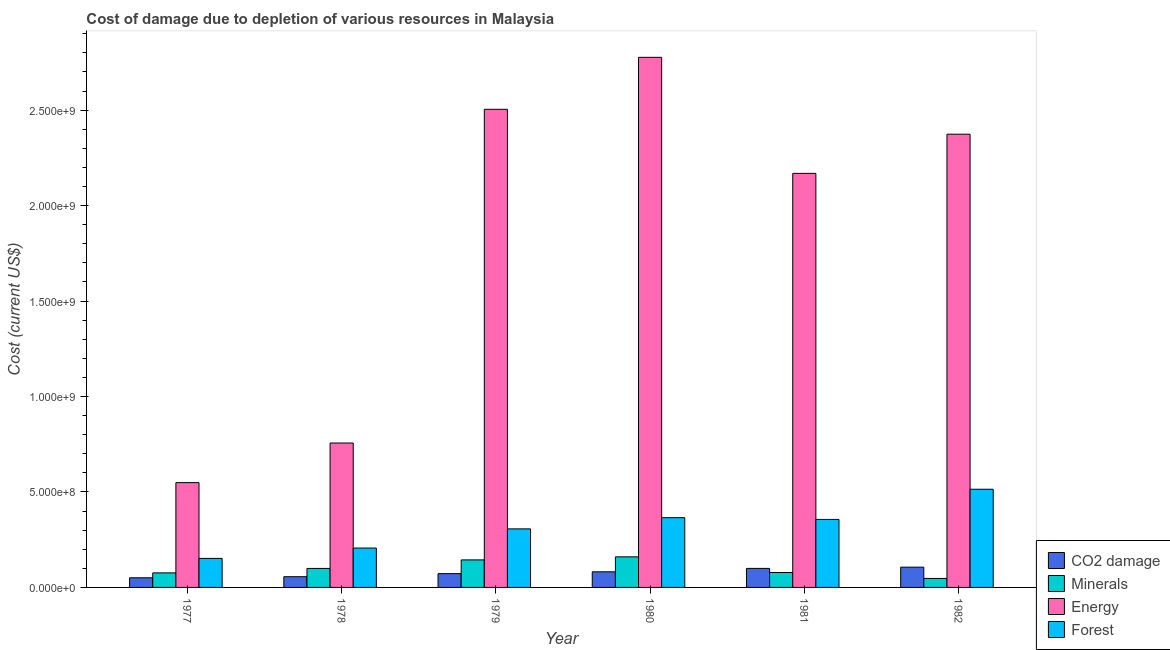How many different coloured bars are there?
Your answer should be compact. 4. How many groups of bars are there?
Your response must be concise. 6. Are the number of bars on each tick of the X-axis equal?
Your answer should be compact. Yes. What is the label of the 2nd group of bars from the left?
Offer a very short reply. 1978. What is the cost of damage due to depletion of forests in 1979?
Your answer should be very brief. 3.07e+08. Across all years, what is the maximum cost of damage due to depletion of energy?
Provide a succinct answer. 2.78e+09. Across all years, what is the minimum cost of damage due to depletion of forests?
Offer a terse response. 1.52e+08. In which year was the cost of damage due to depletion of minerals maximum?
Your response must be concise. 1980. What is the total cost of damage due to depletion of forests in the graph?
Keep it short and to the point. 1.90e+09. What is the difference between the cost of damage due to depletion of energy in 1978 and that in 1979?
Provide a succinct answer. -1.75e+09. What is the difference between the cost of damage due to depletion of forests in 1979 and the cost of damage due to depletion of minerals in 1982?
Provide a short and direct response. -2.08e+08. What is the average cost of damage due to depletion of energy per year?
Your response must be concise. 1.85e+09. What is the ratio of the cost of damage due to depletion of energy in 1977 to that in 1979?
Ensure brevity in your answer.  0.22. What is the difference between the highest and the second highest cost of damage due to depletion of minerals?
Provide a succinct answer. 1.60e+07. What is the difference between the highest and the lowest cost of damage due to depletion of coal?
Provide a short and direct response. 5.57e+07. Is it the case that in every year, the sum of the cost of damage due to depletion of coal and cost of damage due to depletion of minerals is greater than the sum of cost of damage due to depletion of energy and cost of damage due to depletion of forests?
Offer a very short reply. No. What does the 4th bar from the left in 1982 represents?
Your response must be concise. Forest. What does the 1st bar from the right in 1977 represents?
Your answer should be compact. Forest. What is the difference between two consecutive major ticks on the Y-axis?
Offer a terse response. 5.00e+08. Are the values on the major ticks of Y-axis written in scientific E-notation?
Ensure brevity in your answer.  Yes. Does the graph contain grids?
Keep it short and to the point. No. How many legend labels are there?
Give a very brief answer. 4. What is the title of the graph?
Your response must be concise. Cost of damage due to depletion of various resources in Malaysia . What is the label or title of the Y-axis?
Ensure brevity in your answer.  Cost (current US$). What is the Cost (current US$) of CO2 damage in 1977?
Your answer should be very brief. 5.05e+07. What is the Cost (current US$) in Minerals in 1977?
Your answer should be very brief. 7.62e+07. What is the Cost (current US$) of Energy in 1977?
Give a very brief answer. 5.49e+08. What is the Cost (current US$) of Forest in 1977?
Your response must be concise. 1.52e+08. What is the Cost (current US$) in CO2 damage in 1978?
Your answer should be very brief. 5.62e+07. What is the Cost (current US$) in Minerals in 1978?
Your answer should be compact. 9.95e+07. What is the Cost (current US$) of Energy in 1978?
Ensure brevity in your answer.  7.56e+08. What is the Cost (current US$) in Forest in 1978?
Your response must be concise. 2.06e+08. What is the Cost (current US$) in CO2 damage in 1979?
Offer a very short reply. 7.23e+07. What is the Cost (current US$) of Minerals in 1979?
Ensure brevity in your answer.  1.44e+08. What is the Cost (current US$) of Energy in 1979?
Ensure brevity in your answer.  2.50e+09. What is the Cost (current US$) in Forest in 1979?
Make the answer very short. 3.07e+08. What is the Cost (current US$) of CO2 damage in 1980?
Your answer should be very brief. 8.18e+07. What is the Cost (current US$) in Minerals in 1980?
Ensure brevity in your answer.  1.60e+08. What is the Cost (current US$) in Energy in 1980?
Provide a succinct answer. 2.78e+09. What is the Cost (current US$) of Forest in 1980?
Provide a short and direct response. 3.65e+08. What is the Cost (current US$) in CO2 damage in 1981?
Keep it short and to the point. 9.96e+07. What is the Cost (current US$) in Minerals in 1981?
Your answer should be compact. 7.82e+07. What is the Cost (current US$) of Energy in 1981?
Give a very brief answer. 2.17e+09. What is the Cost (current US$) in Forest in 1981?
Make the answer very short. 3.56e+08. What is the Cost (current US$) of CO2 damage in 1982?
Provide a short and direct response. 1.06e+08. What is the Cost (current US$) in Minerals in 1982?
Provide a short and direct response. 4.71e+07. What is the Cost (current US$) of Energy in 1982?
Your response must be concise. 2.37e+09. What is the Cost (current US$) of Forest in 1982?
Offer a terse response. 5.14e+08. Across all years, what is the maximum Cost (current US$) of CO2 damage?
Your answer should be very brief. 1.06e+08. Across all years, what is the maximum Cost (current US$) of Minerals?
Your response must be concise. 1.60e+08. Across all years, what is the maximum Cost (current US$) of Energy?
Make the answer very short. 2.78e+09. Across all years, what is the maximum Cost (current US$) in Forest?
Your answer should be compact. 5.14e+08. Across all years, what is the minimum Cost (current US$) in CO2 damage?
Your answer should be very brief. 5.05e+07. Across all years, what is the minimum Cost (current US$) in Minerals?
Provide a succinct answer. 4.71e+07. Across all years, what is the minimum Cost (current US$) of Energy?
Provide a short and direct response. 5.49e+08. Across all years, what is the minimum Cost (current US$) of Forest?
Ensure brevity in your answer.  1.52e+08. What is the total Cost (current US$) of CO2 damage in the graph?
Keep it short and to the point. 4.67e+08. What is the total Cost (current US$) of Minerals in the graph?
Keep it short and to the point. 6.05e+08. What is the total Cost (current US$) in Energy in the graph?
Ensure brevity in your answer.  1.11e+1. What is the total Cost (current US$) in Forest in the graph?
Provide a short and direct response. 1.90e+09. What is the difference between the Cost (current US$) of CO2 damage in 1977 and that in 1978?
Ensure brevity in your answer.  -5.70e+06. What is the difference between the Cost (current US$) in Minerals in 1977 and that in 1978?
Make the answer very short. -2.33e+07. What is the difference between the Cost (current US$) of Energy in 1977 and that in 1978?
Keep it short and to the point. -2.07e+08. What is the difference between the Cost (current US$) in Forest in 1977 and that in 1978?
Make the answer very short. -5.43e+07. What is the difference between the Cost (current US$) in CO2 damage in 1977 and that in 1979?
Your response must be concise. -2.18e+07. What is the difference between the Cost (current US$) in Minerals in 1977 and that in 1979?
Provide a short and direct response. -6.80e+07. What is the difference between the Cost (current US$) of Energy in 1977 and that in 1979?
Ensure brevity in your answer.  -1.96e+09. What is the difference between the Cost (current US$) in Forest in 1977 and that in 1979?
Make the answer very short. -1.55e+08. What is the difference between the Cost (current US$) of CO2 damage in 1977 and that in 1980?
Your answer should be compact. -3.13e+07. What is the difference between the Cost (current US$) in Minerals in 1977 and that in 1980?
Give a very brief answer. -8.40e+07. What is the difference between the Cost (current US$) in Energy in 1977 and that in 1980?
Your response must be concise. -2.23e+09. What is the difference between the Cost (current US$) of Forest in 1977 and that in 1980?
Give a very brief answer. -2.13e+08. What is the difference between the Cost (current US$) in CO2 damage in 1977 and that in 1981?
Keep it short and to the point. -4.91e+07. What is the difference between the Cost (current US$) in Minerals in 1977 and that in 1981?
Offer a terse response. -1.99e+06. What is the difference between the Cost (current US$) of Energy in 1977 and that in 1981?
Ensure brevity in your answer.  -1.62e+09. What is the difference between the Cost (current US$) in Forest in 1977 and that in 1981?
Your answer should be compact. -2.04e+08. What is the difference between the Cost (current US$) in CO2 damage in 1977 and that in 1982?
Provide a succinct answer. -5.57e+07. What is the difference between the Cost (current US$) in Minerals in 1977 and that in 1982?
Offer a terse response. 2.91e+07. What is the difference between the Cost (current US$) in Energy in 1977 and that in 1982?
Offer a terse response. -1.82e+09. What is the difference between the Cost (current US$) of Forest in 1977 and that in 1982?
Make the answer very short. -3.62e+08. What is the difference between the Cost (current US$) of CO2 damage in 1978 and that in 1979?
Give a very brief answer. -1.61e+07. What is the difference between the Cost (current US$) of Minerals in 1978 and that in 1979?
Your response must be concise. -4.46e+07. What is the difference between the Cost (current US$) of Energy in 1978 and that in 1979?
Your answer should be very brief. -1.75e+09. What is the difference between the Cost (current US$) of Forest in 1978 and that in 1979?
Offer a terse response. -1.00e+08. What is the difference between the Cost (current US$) in CO2 damage in 1978 and that in 1980?
Provide a short and direct response. -2.56e+07. What is the difference between the Cost (current US$) of Minerals in 1978 and that in 1980?
Your answer should be compact. -6.06e+07. What is the difference between the Cost (current US$) of Energy in 1978 and that in 1980?
Your response must be concise. -2.02e+09. What is the difference between the Cost (current US$) of Forest in 1978 and that in 1980?
Provide a succinct answer. -1.59e+08. What is the difference between the Cost (current US$) of CO2 damage in 1978 and that in 1981?
Ensure brevity in your answer.  -4.34e+07. What is the difference between the Cost (current US$) in Minerals in 1978 and that in 1981?
Keep it short and to the point. 2.14e+07. What is the difference between the Cost (current US$) in Energy in 1978 and that in 1981?
Offer a terse response. -1.41e+09. What is the difference between the Cost (current US$) in Forest in 1978 and that in 1981?
Offer a terse response. -1.50e+08. What is the difference between the Cost (current US$) in CO2 damage in 1978 and that in 1982?
Your answer should be very brief. -5.00e+07. What is the difference between the Cost (current US$) of Minerals in 1978 and that in 1982?
Keep it short and to the point. 5.24e+07. What is the difference between the Cost (current US$) in Energy in 1978 and that in 1982?
Keep it short and to the point. -1.62e+09. What is the difference between the Cost (current US$) of Forest in 1978 and that in 1982?
Give a very brief answer. -3.08e+08. What is the difference between the Cost (current US$) of CO2 damage in 1979 and that in 1980?
Keep it short and to the point. -9.54e+06. What is the difference between the Cost (current US$) of Minerals in 1979 and that in 1980?
Offer a very short reply. -1.60e+07. What is the difference between the Cost (current US$) in Energy in 1979 and that in 1980?
Your answer should be very brief. -2.72e+08. What is the difference between the Cost (current US$) of Forest in 1979 and that in 1980?
Ensure brevity in your answer.  -5.87e+07. What is the difference between the Cost (current US$) of CO2 damage in 1979 and that in 1981?
Your answer should be compact. -2.74e+07. What is the difference between the Cost (current US$) in Minerals in 1979 and that in 1981?
Your answer should be compact. 6.60e+07. What is the difference between the Cost (current US$) in Energy in 1979 and that in 1981?
Make the answer very short. 3.36e+08. What is the difference between the Cost (current US$) in Forest in 1979 and that in 1981?
Ensure brevity in your answer.  -4.96e+07. What is the difference between the Cost (current US$) of CO2 damage in 1979 and that in 1982?
Your answer should be very brief. -3.39e+07. What is the difference between the Cost (current US$) of Minerals in 1979 and that in 1982?
Provide a short and direct response. 9.70e+07. What is the difference between the Cost (current US$) in Energy in 1979 and that in 1982?
Your answer should be very brief. 1.30e+08. What is the difference between the Cost (current US$) of Forest in 1979 and that in 1982?
Your answer should be compact. -2.08e+08. What is the difference between the Cost (current US$) of CO2 damage in 1980 and that in 1981?
Ensure brevity in your answer.  -1.78e+07. What is the difference between the Cost (current US$) of Minerals in 1980 and that in 1981?
Your answer should be very brief. 8.20e+07. What is the difference between the Cost (current US$) in Energy in 1980 and that in 1981?
Keep it short and to the point. 6.08e+08. What is the difference between the Cost (current US$) of Forest in 1980 and that in 1981?
Keep it short and to the point. 9.09e+06. What is the difference between the Cost (current US$) in CO2 damage in 1980 and that in 1982?
Your response must be concise. -2.44e+07. What is the difference between the Cost (current US$) of Minerals in 1980 and that in 1982?
Offer a terse response. 1.13e+08. What is the difference between the Cost (current US$) of Energy in 1980 and that in 1982?
Provide a short and direct response. 4.03e+08. What is the difference between the Cost (current US$) of Forest in 1980 and that in 1982?
Provide a short and direct response. -1.49e+08. What is the difference between the Cost (current US$) of CO2 damage in 1981 and that in 1982?
Your answer should be very brief. -6.55e+06. What is the difference between the Cost (current US$) of Minerals in 1981 and that in 1982?
Offer a very short reply. 3.10e+07. What is the difference between the Cost (current US$) of Energy in 1981 and that in 1982?
Your answer should be very brief. -2.05e+08. What is the difference between the Cost (current US$) of Forest in 1981 and that in 1982?
Ensure brevity in your answer.  -1.58e+08. What is the difference between the Cost (current US$) in CO2 damage in 1977 and the Cost (current US$) in Minerals in 1978?
Your response must be concise. -4.90e+07. What is the difference between the Cost (current US$) in CO2 damage in 1977 and the Cost (current US$) in Energy in 1978?
Your answer should be compact. -7.06e+08. What is the difference between the Cost (current US$) of CO2 damage in 1977 and the Cost (current US$) of Forest in 1978?
Offer a very short reply. -1.56e+08. What is the difference between the Cost (current US$) of Minerals in 1977 and the Cost (current US$) of Energy in 1978?
Provide a short and direct response. -6.80e+08. What is the difference between the Cost (current US$) in Minerals in 1977 and the Cost (current US$) in Forest in 1978?
Make the answer very short. -1.30e+08. What is the difference between the Cost (current US$) of Energy in 1977 and the Cost (current US$) of Forest in 1978?
Offer a terse response. 3.43e+08. What is the difference between the Cost (current US$) of CO2 damage in 1977 and the Cost (current US$) of Minerals in 1979?
Provide a short and direct response. -9.37e+07. What is the difference between the Cost (current US$) in CO2 damage in 1977 and the Cost (current US$) in Energy in 1979?
Give a very brief answer. -2.45e+09. What is the difference between the Cost (current US$) in CO2 damage in 1977 and the Cost (current US$) in Forest in 1979?
Offer a very short reply. -2.56e+08. What is the difference between the Cost (current US$) of Minerals in 1977 and the Cost (current US$) of Energy in 1979?
Ensure brevity in your answer.  -2.43e+09. What is the difference between the Cost (current US$) of Minerals in 1977 and the Cost (current US$) of Forest in 1979?
Provide a succinct answer. -2.30e+08. What is the difference between the Cost (current US$) of Energy in 1977 and the Cost (current US$) of Forest in 1979?
Offer a terse response. 2.42e+08. What is the difference between the Cost (current US$) of CO2 damage in 1977 and the Cost (current US$) of Minerals in 1980?
Ensure brevity in your answer.  -1.10e+08. What is the difference between the Cost (current US$) of CO2 damage in 1977 and the Cost (current US$) of Energy in 1980?
Make the answer very short. -2.73e+09. What is the difference between the Cost (current US$) in CO2 damage in 1977 and the Cost (current US$) in Forest in 1980?
Your answer should be very brief. -3.15e+08. What is the difference between the Cost (current US$) in Minerals in 1977 and the Cost (current US$) in Energy in 1980?
Your response must be concise. -2.70e+09. What is the difference between the Cost (current US$) of Minerals in 1977 and the Cost (current US$) of Forest in 1980?
Ensure brevity in your answer.  -2.89e+08. What is the difference between the Cost (current US$) in Energy in 1977 and the Cost (current US$) in Forest in 1980?
Offer a very short reply. 1.84e+08. What is the difference between the Cost (current US$) of CO2 damage in 1977 and the Cost (current US$) of Minerals in 1981?
Keep it short and to the point. -2.77e+07. What is the difference between the Cost (current US$) of CO2 damage in 1977 and the Cost (current US$) of Energy in 1981?
Provide a short and direct response. -2.12e+09. What is the difference between the Cost (current US$) of CO2 damage in 1977 and the Cost (current US$) of Forest in 1981?
Offer a terse response. -3.06e+08. What is the difference between the Cost (current US$) in Minerals in 1977 and the Cost (current US$) in Energy in 1981?
Provide a short and direct response. -2.09e+09. What is the difference between the Cost (current US$) of Minerals in 1977 and the Cost (current US$) of Forest in 1981?
Give a very brief answer. -2.80e+08. What is the difference between the Cost (current US$) in Energy in 1977 and the Cost (current US$) in Forest in 1981?
Your answer should be very brief. 1.93e+08. What is the difference between the Cost (current US$) in CO2 damage in 1977 and the Cost (current US$) in Minerals in 1982?
Your response must be concise. 3.37e+06. What is the difference between the Cost (current US$) of CO2 damage in 1977 and the Cost (current US$) of Energy in 1982?
Offer a very short reply. -2.32e+09. What is the difference between the Cost (current US$) of CO2 damage in 1977 and the Cost (current US$) of Forest in 1982?
Your answer should be very brief. -4.64e+08. What is the difference between the Cost (current US$) in Minerals in 1977 and the Cost (current US$) in Energy in 1982?
Keep it short and to the point. -2.30e+09. What is the difference between the Cost (current US$) in Minerals in 1977 and the Cost (current US$) in Forest in 1982?
Offer a terse response. -4.38e+08. What is the difference between the Cost (current US$) of Energy in 1977 and the Cost (current US$) of Forest in 1982?
Offer a very short reply. 3.47e+07. What is the difference between the Cost (current US$) of CO2 damage in 1978 and the Cost (current US$) of Minerals in 1979?
Give a very brief answer. -8.80e+07. What is the difference between the Cost (current US$) of CO2 damage in 1978 and the Cost (current US$) of Energy in 1979?
Your answer should be compact. -2.45e+09. What is the difference between the Cost (current US$) in CO2 damage in 1978 and the Cost (current US$) in Forest in 1979?
Offer a terse response. -2.50e+08. What is the difference between the Cost (current US$) in Minerals in 1978 and the Cost (current US$) in Energy in 1979?
Your response must be concise. -2.40e+09. What is the difference between the Cost (current US$) of Minerals in 1978 and the Cost (current US$) of Forest in 1979?
Provide a short and direct response. -2.07e+08. What is the difference between the Cost (current US$) of Energy in 1978 and the Cost (current US$) of Forest in 1979?
Provide a short and direct response. 4.50e+08. What is the difference between the Cost (current US$) of CO2 damage in 1978 and the Cost (current US$) of Minerals in 1980?
Your answer should be very brief. -1.04e+08. What is the difference between the Cost (current US$) of CO2 damage in 1978 and the Cost (current US$) of Energy in 1980?
Keep it short and to the point. -2.72e+09. What is the difference between the Cost (current US$) in CO2 damage in 1978 and the Cost (current US$) in Forest in 1980?
Your answer should be compact. -3.09e+08. What is the difference between the Cost (current US$) in Minerals in 1978 and the Cost (current US$) in Energy in 1980?
Provide a succinct answer. -2.68e+09. What is the difference between the Cost (current US$) in Minerals in 1978 and the Cost (current US$) in Forest in 1980?
Offer a very short reply. -2.66e+08. What is the difference between the Cost (current US$) of Energy in 1978 and the Cost (current US$) of Forest in 1980?
Offer a terse response. 3.91e+08. What is the difference between the Cost (current US$) of CO2 damage in 1978 and the Cost (current US$) of Minerals in 1981?
Provide a short and direct response. -2.20e+07. What is the difference between the Cost (current US$) of CO2 damage in 1978 and the Cost (current US$) of Energy in 1981?
Ensure brevity in your answer.  -2.11e+09. What is the difference between the Cost (current US$) of CO2 damage in 1978 and the Cost (current US$) of Forest in 1981?
Keep it short and to the point. -3.00e+08. What is the difference between the Cost (current US$) of Minerals in 1978 and the Cost (current US$) of Energy in 1981?
Offer a terse response. -2.07e+09. What is the difference between the Cost (current US$) of Minerals in 1978 and the Cost (current US$) of Forest in 1981?
Provide a short and direct response. -2.57e+08. What is the difference between the Cost (current US$) of Energy in 1978 and the Cost (current US$) of Forest in 1981?
Offer a very short reply. 4.00e+08. What is the difference between the Cost (current US$) in CO2 damage in 1978 and the Cost (current US$) in Minerals in 1982?
Give a very brief answer. 9.07e+06. What is the difference between the Cost (current US$) of CO2 damage in 1978 and the Cost (current US$) of Energy in 1982?
Offer a very short reply. -2.32e+09. What is the difference between the Cost (current US$) of CO2 damage in 1978 and the Cost (current US$) of Forest in 1982?
Provide a short and direct response. -4.58e+08. What is the difference between the Cost (current US$) of Minerals in 1978 and the Cost (current US$) of Energy in 1982?
Your answer should be compact. -2.27e+09. What is the difference between the Cost (current US$) in Minerals in 1978 and the Cost (current US$) in Forest in 1982?
Make the answer very short. -4.15e+08. What is the difference between the Cost (current US$) of Energy in 1978 and the Cost (current US$) of Forest in 1982?
Your response must be concise. 2.42e+08. What is the difference between the Cost (current US$) of CO2 damage in 1979 and the Cost (current US$) of Minerals in 1980?
Offer a terse response. -8.79e+07. What is the difference between the Cost (current US$) in CO2 damage in 1979 and the Cost (current US$) in Energy in 1980?
Offer a very short reply. -2.70e+09. What is the difference between the Cost (current US$) in CO2 damage in 1979 and the Cost (current US$) in Forest in 1980?
Make the answer very short. -2.93e+08. What is the difference between the Cost (current US$) in Minerals in 1979 and the Cost (current US$) in Energy in 1980?
Give a very brief answer. -2.63e+09. What is the difference between the Cost (current US$) in Minerals in 1979 and the Cost (current US$) in Forest in 1980?
Your answer should be very brief. -2.21e+08. What is the difference between the Cost (current US$) in Energy in 1979 and the Cost (current US$) in Forest in 1980?
Give a very brief answer. 2.14e+09. What is the difference between the Cost (current US$) in CO2 damage in 1979 and the Cost (current US$) in Minerals in 1981?
Keep it short and to the point. -5.92e+06. What is the difference between the Cost (current US$) in CO2 damage in 1979 and the Cost (current US$) in Energy in 1981?
Offer a very short reply. -2.10e+09. What is the difference between the Cost (current US$) of CO2 damage in 1979 and the Cost (current US$) of Forest in 1981?
Your answer should be compact. -2.84e+08. What is the difference between the Cost (current US$) in Minerals in 1979 and the Cost (current US$) in Energy in 1981?
Give a very brief answer. -2.02e+09. What is the difference between the Cost (current US$) of Minerals in 1979 and the Cost (current US$) of Forest in 1981?
Ensure brevity in your answer.  -2.12e+08. What is the difference between the Cost (current US$) in Energy in 1979 and the Cost (current US$) in Forest in 1981?
Your answer should be compact. 2.15e+09. What is the difference between the Cost (current US$) of CO2 damage in 1979 and the Cost (current US$) of Minerals in 1982?
Your answer should be very brief. 2.51e+07. What is the difference between the Cost (current US$) of CO2 damage in 1979 and the Cost (current US$) of Energy in 1982?
Ensure brevity in your answer.  -2.30e+09. What is the difference between the Cost (current US$) in CO2 damage in 1979 and the Cost (current US$) in Forest in 1982?
Give a very brief answer. -4.42e+08. What is the difference between the Cost (current US$) in Minerals in 1979 and the Cost (current US$) in Energy in 1982?
Provide a succinct answer. -2.23e+09. What is the difference between the Cost (current US$) in Minerals in 1979 and the Cost (current US$) in Forest in 1982?
Ensure brevity in your answer.  -3.70e+08. What is the difference between the Cost (current US$) of Energy in 1979 and the Cost (current US$) of Forest in 1982?
Offer a terse response. 1.99e+09. What is the difference between the Cost (current US$) in CO2 damage in 1980 and the Cost (current US$) in Minerals in 1981?
Make the answer very short. 3.62e+06. What is the difference between the Cost (current US$) of CO2 damage in 1980 and the Cost (current US$) of Energy in 1981?
Make the answer very short. -2.09e+09. What is the difference between the Cost (current US$) of CO2 damage in 1980 and the Cost (current US$) of Forest in 1981?
Provide a short and direct response. -2.74e+08. What is the difference between the Cost (current US$) of Minerals in 1980 and the Cost (current US$) of Energy in 1981?
Make the answer very short. -2.01e+09. What is the difference between the Cost (current US$) of Minerals in 1980 and the Cost (current US$) of Forest in 1981?
Offer a terse response. -1.96e+08. What is the difference between the Cost (current US$) of Energy in 1980 and the Cost (current US$) of Forest in 1981?
Offer a very short reply. 2.42e+09. What is the difference between the Cost (current US$) of CO2 damage in 1980 and the Cost (current US$) of Minerals in 1982?
Give a very brief answer. 3.47e+07. What is the difference between the Cost (current US$) of CO2 damage in 1980 and the Cost (current US$) of Energy in 1982?
Make the answer very short. -2.29e+09. What is the difference between the Cost (current US$) in CO2 damage in 1980 and the Cost (current US$) in Forest in 1982?
Offer a very short reply. -4.32e+08. What is the difference between the Cost (current US$) in Minerals in 1980 and the Cost (current US$) in Energy in 1982?
Your answer should be very brief. -2.21e+09. What is the difference between the Cost (current US$) in Minerals in 1980 and the Cost (current US$) in Forest in 1982?
Ensure brevity in your answer.  -3.54e+08. What is the difference between the Cost (current US$) of Energy in 1980 and the Cost (current US$) of Forest in 1982?
Provide a short and direct response. 2.26e+09. What is the difference between the Cost (current US$) in CO2 damage in 1981 and the Cost (current US$) in Minerals in 1982?
Provide a short and direct response. 5.25e+07. What is the difference between the Cost (current US$) of CO2 damage in 1981 and the Cost (current US$) of Energy in 1982?
Give a very brief answer. -2.27e+09. What is the difference between the Cost (current US$) in CO2 damage in 1981 and the Cost (current US$) in Forest in 1982?
Provide a succinct answer. -4.15e+08. What is the difference between the Cost (current US$) in Minerals in 1981 and the Cost (current US$) in Energy in 1982?
Keep it short and to the point. -2.30e+09. What is the difference between the Cost (current US$) in Minerals in 1981 and the Cost (current US$) in Forest in 1982?
Your response must be concise. -4.36e+08. What is the difference between the Cost (current US$) of Energy in 1981 and the Cost (current US$) of Forest in 1982?
Your answer should be compact. 1.65e+09. What is the average Cost (current US$) of CO2 damage per year?
Ensure brevity in your answer.  7.78e+07. What is the average Cost (current US$) of Minerals per year?
Make the answer very short. 1.01e+08. What is the average Cost (current US$) of Energy per year?
Provide a short and direct response. 1.85e+09. What is the average Cost (current US$) in Forest per year?
Offer a very short reply. 3.17e+08. In the year 1977, what is the difference between the Cost (current US$) in CO2 damage and Cost (current US$) in Minerals?
Give a very brief answer. -2.57e+07. In the year 1977, what is the difference between the Cost (current US$) of CO2 damage and Cost (current US$) of Energy?
Provide a succinct answer. -4.99e+08. In the year 1977, what is the difference between the Cost (current US$) of CO2 damage and Cost (current US$) of Forest?
Provide a short and direct response. -1.02e+08. In the year 1977, what is the difference between the Cost (current US$) of Minerals and Cost (current US$) of Energy?
Give a very brief answer. -4.73e+08. In the year 1977, what is the difference between the Cost (current US$) of Minerals and Cost (current US$) of Forest?
Offer a terse response. -7.58e+07. In the year 1977, what is the difference between the Cost (current US$) in Energy and Cost (current US$) in Forest?
Offer a terse response. 3.97e+08. In the year 1978, what is the difference between the Cost (current US$) of CO2 damage and Cost (current US$) of Minerals?
Your answer should be very brief. -4.33e+07. In the year 1978, what is the difference between the Cost (current US$) of CO2 damage and Cost (current US$) of Energy?
Make the answer very short. -7.00e+08. In the year 1978, what is the difference between the Cost (current US$) in CO2 damage and Cost (current US$) in Forest?
Provide a succinct answer. -1.50e+08. In the year 1978, what is the difference between the Cost (current US$) of Minerals and Cost (current US$) of Energy?
Provide a short and direct response. -6.57e+08. In the year 1978, what is the difference between the Cost (current US$) in Minerals and Cost (current US$) in Forest?
Provide a succinct answer. -1.07e+08. In the year 1978, what is the difference between the Cost (current US$) of Energy and Cost (current US$) of Forest?
Your response must be concise. 5.50e+08. In the year 1979, what is the difference between the Cost (current US$) in CO2 damage and Cost (current US$) in Minerals?
Your response must be concise. -7.19e+07. In the year 1979, what is the difference between the Cost (current US$) in CO2 damage and Cost (current US$) in Energy?
Give a very brief answer. -2.43e+09. In the year 1979, what is the difference between the Cost (current US$) in CO2 damage and Cost (current US$) in Forest?
Make the answer very short. -2.34e+08. In the year 1979, what is the difference between the Cost (current US$) of Minerals and Cost (current US$) of Energy?
Your answer should be very brief. -2.36e+09. In the year 1979, what is the difference between the Cost (current US$) of Minerals and Cost (current US$) of Forest?
Provide a succinct answer. -1.62e+08. In the year 1979, what is the difference between the Cost (current US$) in Energy and Cost (current US$) in Forest?
Give a very brief answer. 2.20e+09. In the year 1980, what is the difference between the Cost (current US$) of CO2 damage and Cost (current US$) of Minerals?
Offer a very short reply. -7.84e+07. In the year 1980, what is the difference between the Cost (current US$) of CO2 damage and Cost (current US$) of Energy?
Offer a terse response. -2.69e+09. In the year 1980, what is the difference between the Cost (current US$) in CO2 damage and Cost (current US$) in Forest?
Ensure brevity in your answer.  -2.84e+08. In the year 1980, what is the difference between the Cost (current US$) of Minerals and Cost (current US$) of Energy?
Your answer should be very brief. -2.62e+09. In the year 1980, what is the difference between the Cost (current US$) of Minerals and Cost (current US$) of Forest?
Your answer should be compact. -2.05e+08. In the year 1980, what is the difference between the Cost (current US$) in Energy and Cost (current US$) in Forest?
Make the answer very short. 2.41e+09. In the year 1981, what is the difference between the Cost (current US$) in CO2 damage and Cost (current US$) in Minerals?
Ensure brevity in your answer.  2.14e+07. In the year 1981, what is the difference between the Cost (current US$) in CO2 damage and Cost (current US$) in Energy?
Keep it short and to the point. -2.07e+09. In the year 1981, what is the difference between the Cost (current US$) of CO2 damage and Cost (current US$) of Forest?
Offer a terse response. -2.57e+08. In the year 1981, what is the difference between the Cost (current US$) of Minerals and Cost (current US$) of Energy?
Your answer should be compact. -2.09e+09. In the year 1981, what is the difference between the Cost (current US$) of Minerals and Cost (current US$) of Forest?
Offer a very short reply. -2.78e+08. In the year 1981, what is the difference between the Cost (current US$) of Energy and Cost (current US$) of Forest?
Provide a short and direct response. 1.81e+09. In the year 1982, what is the difference between the Cost (current US$) in CO2 damage and Cost (current US$) in Minerals?
Provide a short and direct response. 5.90e+07. In the year 1982, what is the difference between the Cost (current US$) in CO2 damage and Cost (current US$) in Energy?
Offer a very short reply. -2.27e+09. In the year 1982, what is the difference between the Cost (current US$) of CO2 damage and Cost (current US$) of Forest?
Provide a succinct answer. -4.08e+08. In the year 1982, what is the difference between the Cost (current US$) in Minerals and Cost (current US$) in Energy?
Provide a short and direct response. -2.33e+09. In the year 1982, what is the difference between the Cost (current US$) in Minerals and Cost (current US$) in Forest?
Keep it short and to the point. -4.67e+08. In the year 1982, what is the difference between the Cost (current US$) of Energy and Cost (current US$) of Forest?
Your answer should be compact. 1.86e+09. What is the ratio of the Cost (current US$) of CO2 damage in 1977 to that in 1978?
Provide a short and direct response. 0.9. What is the ratio of the Cost (current US$) in Minerals in 1977 to that in 1978?
Give a very brief answer. 0.77. What is the ratio of the Cost (current US$) in Energy in 1977 to that in 1978?
Your response must be concise. 0.73. What is the ratio of the Cost (current US$) in Forest in 1977 to that in 1978?
Your answer should be compact. 0.74. What is the ratio of the Cost (current US$) of CO2 damage in 1977 to that in 1979?
Offer a very short reply. 0.7. What is the ratio of the Cost (current US$) in Minerals in 1977 to that in 1979?
Provide a short and direct response. 0.53. What is the ratio of the Cost (current US$) of Energy in 1977 to that in 1979?
Ensure brevity in your answer.  0.22. What is the ratio of the Cost (current US$) in Forest in 1977 to that in 1979?
Make the answer very short. 0.5. What is the ratio of the Cost (current US$) in CO2 damage in 1977 to that in 1980?
Provide a short and direct response. 0.62. What is the ratio of the Cost (current US$) in Minerals in 1977 to that in 1980?
Ensure brevity in your answer.  0.48. What is the ratio of the Cost (current US$) of Energy in 1977 to that in 1980?
Make the answer very short. 0.2. What is the ratio of the Cost (current US$) in Forest in 1977 to that in 1980?
Your answer should be very brief. 0.42. What is the ratio of the Cost (current US$) of CO2 damage in 1977 to that in 1981?
Provide a succinct answer. 0.51. What is the ratio of the Cost (current US$) in Minerals in 1977 to that in 1981?
Your answer should be very brief. 0.97. What is the ratio of the Cost (current US$) in Energy in 1977 to that in 1981?
Your response must be concise. 0.25. What is the ratio of the Cost (current US$) in Forest in 1977 to that in 1981?
Ensure brevity in your answer.  0.43. What is the ratio of the Cost (current US$) in CO2 damage in 1977 to that in 1982?
Make the answer very short. 0.48. What is the ratio of the Cost (current US$) in Minerals in 1977 to that in 1982?
Keep it short and to the point. 1.62. What is the ratio of the Cost (current US$) in Energy in 1977 to that in 1982?
Your response must be concise. 0.23. What is the ratio of the Cost (current US$) of Forest in 1977 to that in 1982?
Your answer should be very brief. 0.3. What is the ratio of the Cost (current US$) in CO2 damage in 1978 to that in 1979?
Your response must be concise. 0.78. What is the ratio of the Cost (current US$) in Minerals in 1978 to that in 1979?
Your response must be concise. 0.69. What is the ratio of the Cost (current US$) in Energy in 1978 to that in 1979?
Your answer should be compact. 0.3. What is the ratio of the Cost (current US$) of Forest in 1978 to that in 1979?
Keep it short and to the point. 0.67. What is the ratio of the Cost (current US$) in CO2 damage in 1978 to that in 1980?
Provide a succinct answer. 0.69. What is the ratio of the Cost (current US$) in Minerals in 1978 to that in 1980?
Offer a very short reply. 0.62. What is the ratio of the Cost (current US$) of Energy in 1978 to that in 1980?
Make the answer very short. 0.27. What is the ratio of the Cost (current US$) in Forest in 1978 to that in 1980?
Give a very brief answer. 0.56. What is the ratio of the Cost (current US$) in CO2 damage in 1978 to that in 1981?
Make the answer very short. 0.56. What is the ratio of the Cost (current US$) in Minerals in 1978 to that in 1981?
Your response must be concise. 1.27. What is the ratio of the Cost (current US$) in Energy in 1978 to that in 1981?
Keep it short and to the point. 0.35. What is the ratio of the Cost (current US$) of Forest in 1978 to that in 1981?
Ensure brevity in your answer.  0.58. What is the ratio of the Cost (current US$) in CO2 damage in 1978 to that in 1982?
Ensure brevity in your answer.  0.53. What is the ratio of the Cost (current US$) of Minerals in 1978 to that in 1982?
Your answer should be compact. 2.11. What is the ratio of the Cost (current US$) in Energy in 1978 to that in 1982?
Your answer should be very brief. 0.32. What is the ratio of the Cost (current US$) of Forest in 1978 to that in 1982?
Offer a terse response. 0.4. What is the ratio of the Cost (current US$) in CO2 damage in 1979 to that in 1980?
Make the answer very short. 0.88. What is the ratio of the Cost (current US$) of Minerals in 1979 to that in 1980?
Ensure brevity in your answer.  0.9. What is the ratio of the Cost (current US$) in Energy in 1979 to that in 1980?
Give a very brief answer. 0.9. What is the ratio of the Cost (current US$) of Forest in 1979 to that in 1980?
Give a very brief answer. 0.84. What is the ratio of the Cost (current US$) of CO2 damage in 1979 to that in 1981?
Your answer should be very brief. 0.73. What is the ratio of the Cost (current US$) in Minerals in 1979 to that in 1981?
Offer a terse response. 1.84. What is the ratio of the Cost (current US$) of Energy in 1979 to that in 1981?
Give a very brief answer. 1.15. What is the ratio of the Cost (current US$) of Forest in 1979 to that in 1981?
Offer a very short reply. 0.86. What is the ratio of the Cost (current US$) in CO2 damage in 1979 to that in 1982?
Your response must be concise. 0.68. What is the ratio of the Cost (current US$) of Minerals in 1979 to that in 1982?
Ensure brevity in your answer.  3.06. What is the ratio of the Cost (current US$) of Energy in 1979 to that in 1982?
Give a very brief answer. 1.05. What is the ratio of the Cost (current US$) of Forest in 1979 to that in 1982?
Provide a succinct answer. 0.6. What is the ratio of the Cost (current US$) of CO2 damage in 1980 to that in 1981?
Provide a succinct answer. 0.82. What is the ratio of the Cost (current US$) in Minerals in 1980 to that in 1981?
Provide a succinct answer. 2.05. What is the ratio of the Cost (current US$) in Energy in 1980 to that in 1981?
Make the answer very short. 1.28. What is the ratio of the Cost (current US$) in Forest in 1980 to that in 1981?
Your answer should be very brief. 1.03. What is the ratio of the Cost (current US$) of CO2 damage in 1980 to that in 1982?
Your response must be concise. 0.77. What is the ratio of the Cost (current US$) in Minerals in 1980 to that in 1982?
Ensure brevity in your answer.  3.4. What is the ratio of the Cost (current US$) in Energy in 1980 to that in 1982?
Offer a very short reply. 1.17. What is the ratio of the Cost (current US$) of Forest in 1980 to that in 1982?
Your response must be concise. 0.71. What is the ratio of the Cost (current US$) of CO2 damage in 1981 to that in 1982?
Your response must be concise. 0.94. What is the ratio of the Cost (current US$) in Minerals in 1981 to that in 1982?
Your response must be concise. 1.66. What is the ratio of the Cost (current US$) in Energy in 1981 to that in 1982?
Your response must be concise. 0.91. What is the ratio of the Cost (current US$) in Forest in 1981 to that in 1982?
Provide a succinct answer. 0.69. What is the difference between the highest and the second highest Cost (current US$) in CO2 damage?
Your response must be concise. 6.55e+06. What is the difference between the highest and the second highest Cost (current US$) of Minerals?
Make the answer very short. 1.60e+07. What is the difference between the highest and the second highest Cost (current US$) of Energy?
Your answer should be compact. 2.72e+08. What is the difference between the highest and the second highest Cost (current US$) of Forest?
Your answer should be very brief. 1.49e+08. What is the difference between the highest and the lowest Cost (current US$) of CO2 damage?
Your answer should be compact. 5.57e+07. What is the difference between the highest and the lowest Cost (current US$) in Minerals?
Give a very brief answer. 1.13e+08. What is the difference between the highest and the lowest Cost (current US$) in Energy?
Offer a very short reply. 2.23e+09. What is the difference between the highest and the lowest Cost (current US$) of Forest?
Provide a short and direct response. 3.62e+08. 